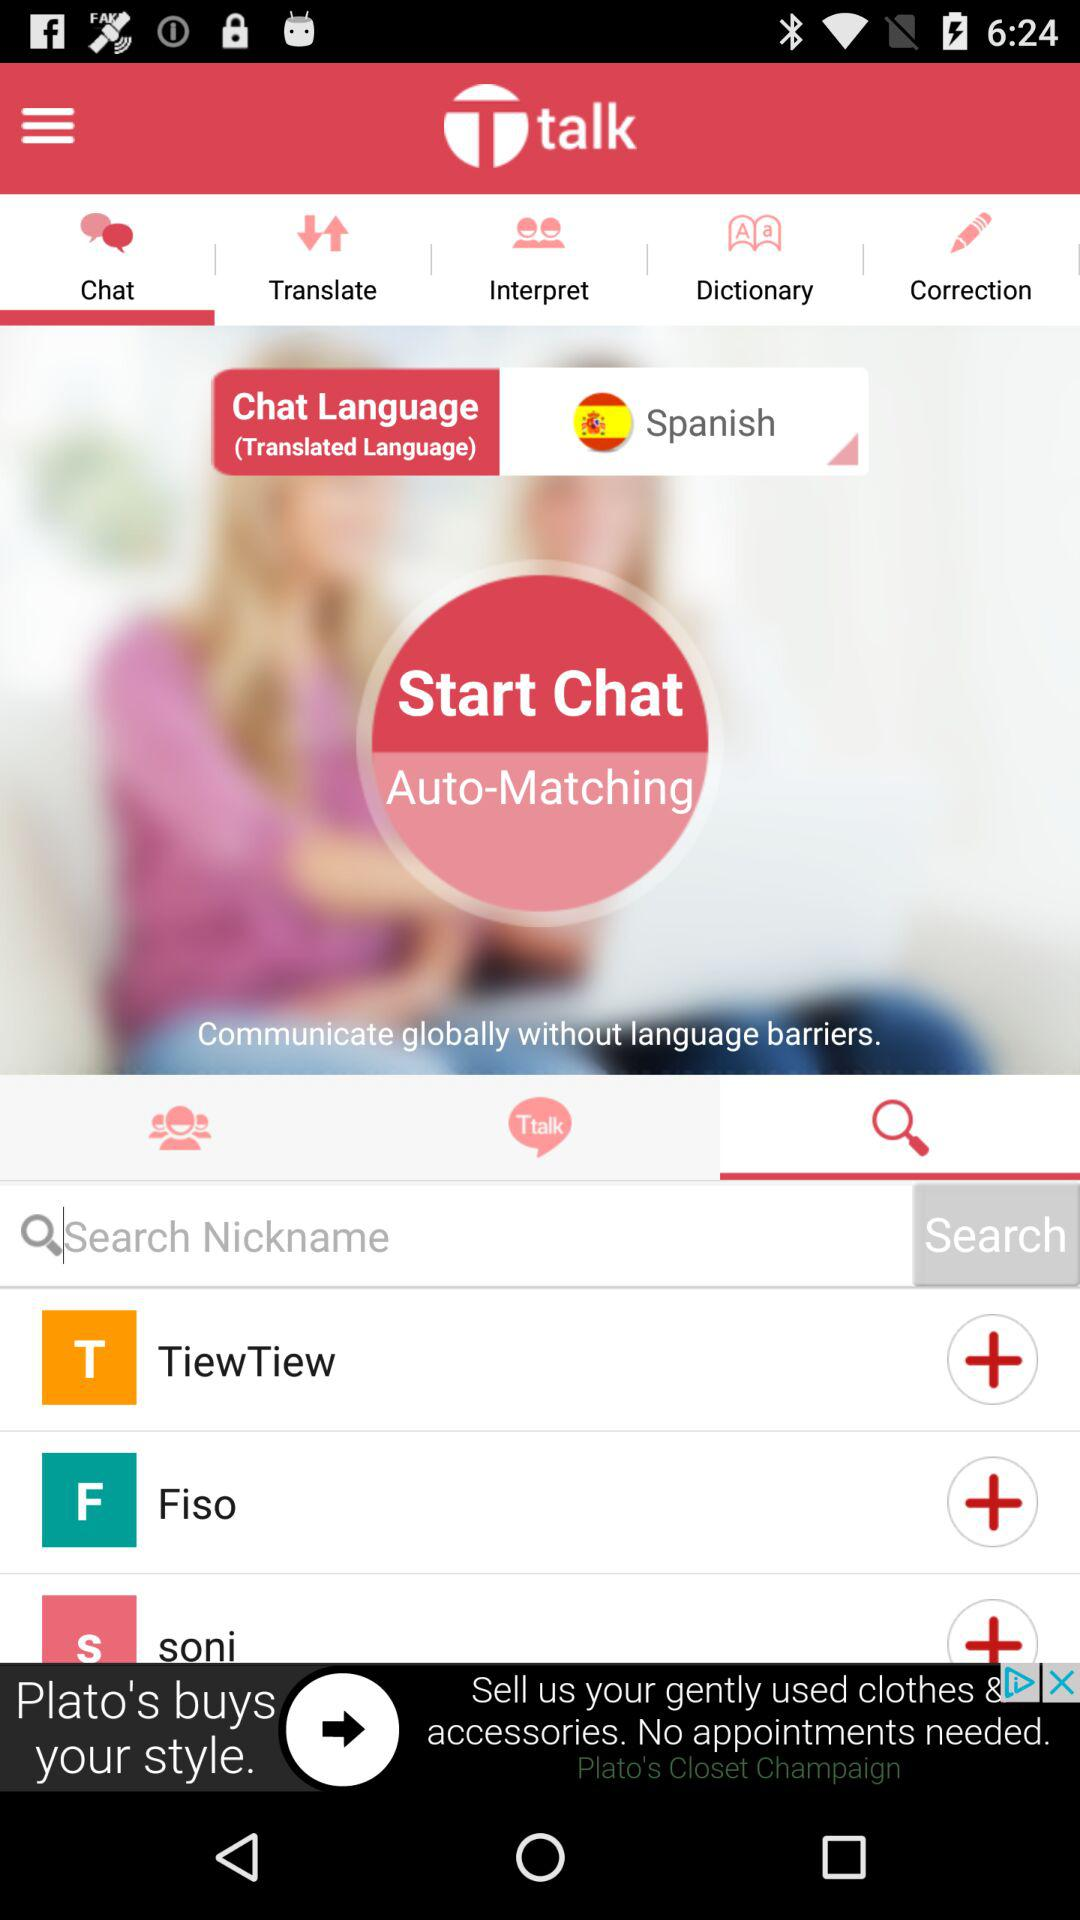What is the name of the application? The name of the application is "talk". 